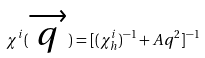<formula> <loc_0><loc_0><loc_500><loc_500>\chi ^ { i } ( \overrightarrow { q } ) = [ ( \chi _ { h } ^ { i } ) ^ { - 1 } + A q ^ { 2 } ] ^ { - 1 }</formula> 